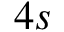<formula> <loc_0><loc_0><loc_500><loc_500>4 s</formula> 